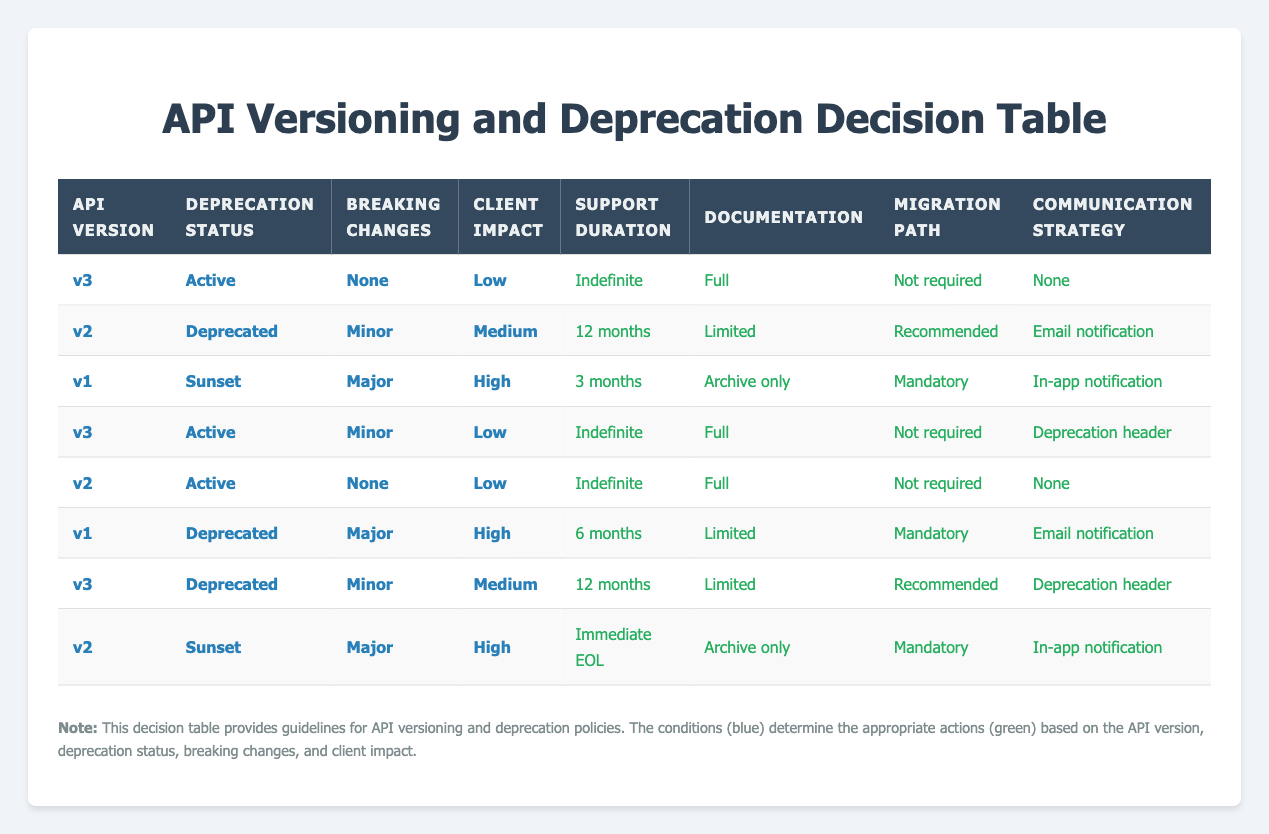What is the support duration for API version v3 that is active with no breaking changes and low client impact? According to the table, for v3, when the deprecation status is Active, breaking changes are None, and client impact is Low, the support duration is stated as Indefinite.
Answer: Indefinite How many months of support does a deprecated v1 API with major breaking changes and high client impact receive? For v1, the deprecation status is Deprecated, with Major breaking changes and High client impact listed, the support duration provided is 6 months.
Answer: 6 months Is v2 API with a deprecated status and minor breaking changes considered to have a communication strategy? The row for v2 with a deprecated status and minor breaking changes indicates that its communication strategy is specified as Email notification, which means it has a communication strategy in place.
Answer: Yes What are the documentation options for API version v3 that is deprecated and has minor breaking changes with medium client impact? The table shows that for v3, when the status is Deprecated, it has minor breaking changes and medium client impact, the documentation option is stated as Limited.
Answer: Limited If we analyze the deprecation policies, how many APIs are rendered as having a support duration of 12 months? We need to examine the table for any rows with a support duration of 12 months. There are two rows fulfilling these criteria: the deprecated v2 API with minor breaking changes and medium client impact and the deprecated v3 API with minor breaking changes and medium client impact. Thus, there are two APIs with a support duration of 12 months.
Answer: 2 What action is taken for a deprecated v2 API with major breaking changes and high client impact? When reviewing the table, for v2 that is in Sunset stage and has Major breaking changes as well as High client impact, the support duration listed is Immediate EOL, along with an Archive only documentation and Mandatory migration path with In-app notification as a communication strategy.
Answer: Immediate EOL How does the support duration compare between an active v2 API with no breaking changes and a deprecated v1 API with major breaking changes? Comparing the two rows, the active v2 API with no breaking changes has a support duration of Indefinite, while the deprecated v1 API with major breaking changes has a support duration of 6 months. Thus, the support duration for the active v2 API is longer.
Answer: Active v2 is longer Is the migration path for an active v3 API that has minor breaking changes and low client impact mandatory? The relevant row shows that for v3, when active, minor breaking changes and low client impact exist, the migration path is Not required, meaning it is not mandatory.
Answer: No 